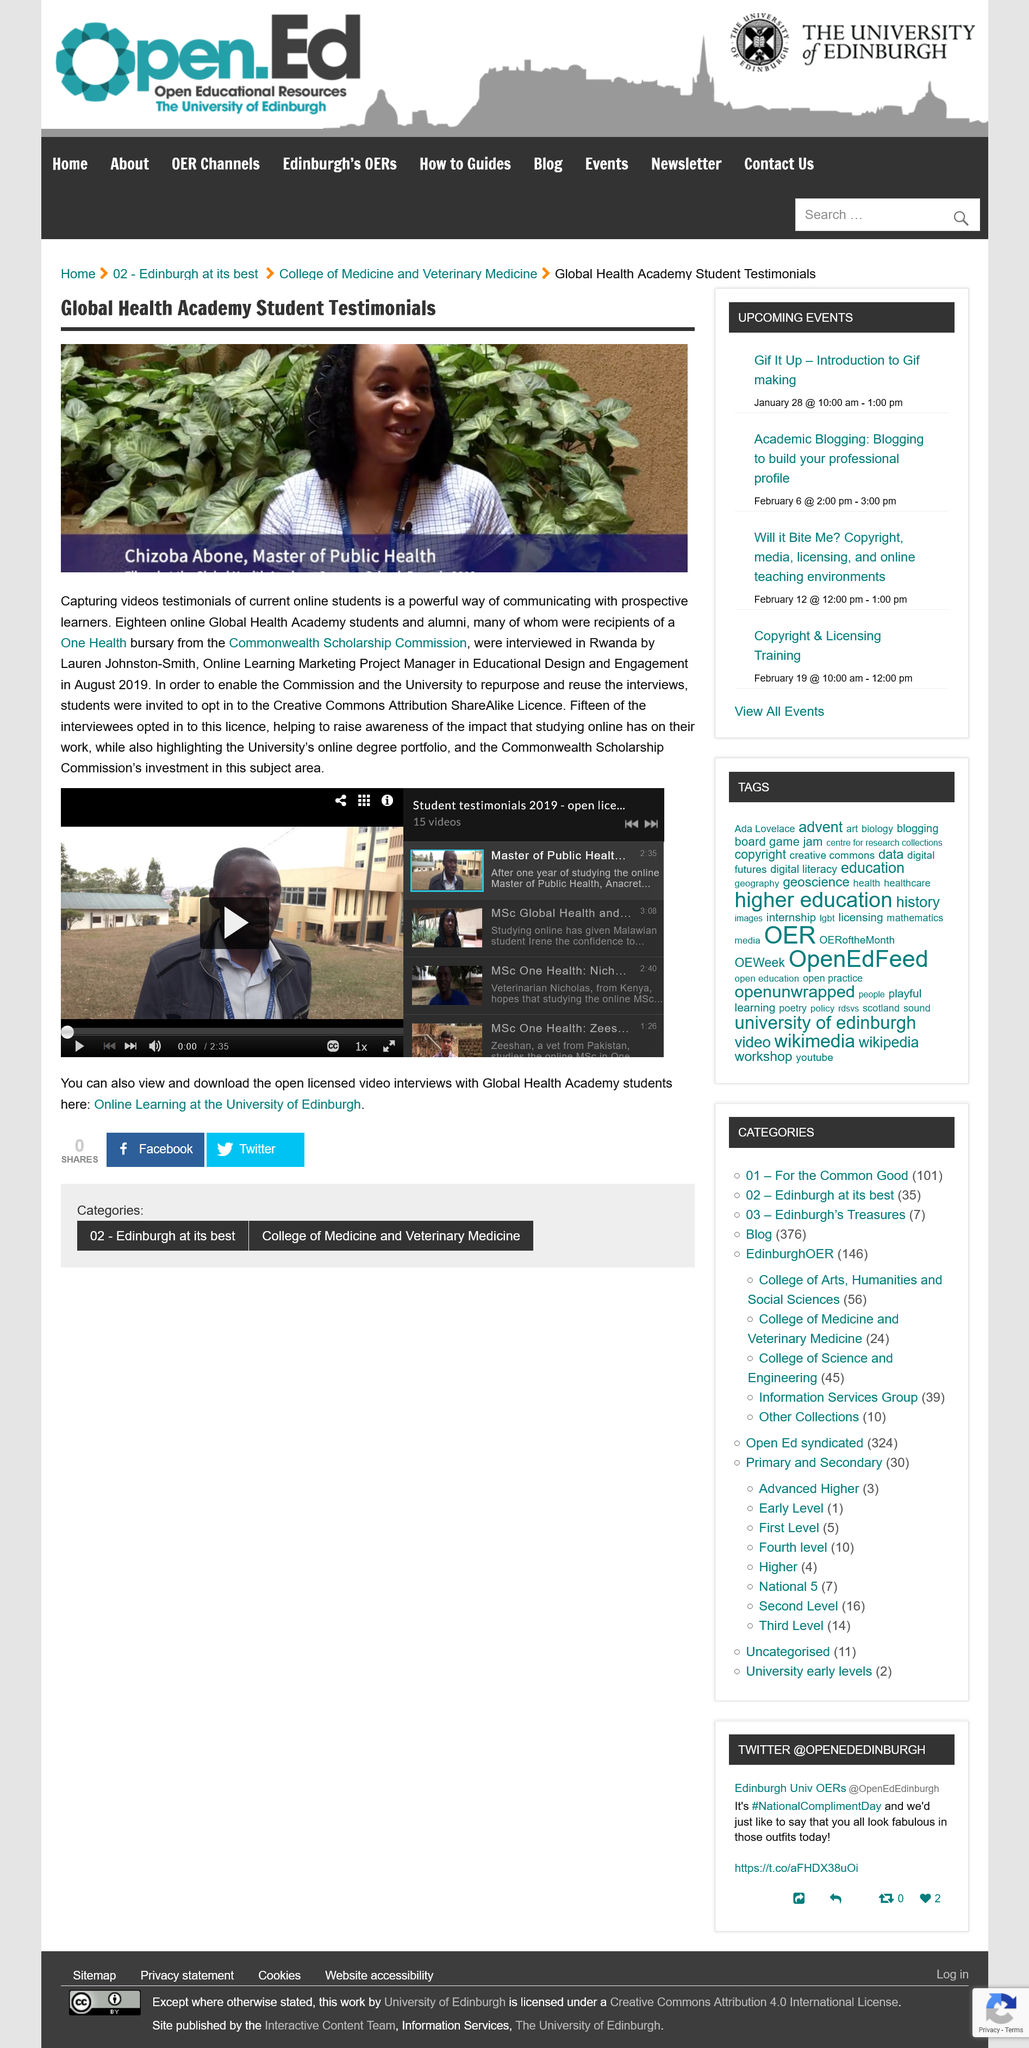Highlight a few significant elements in this photo. Chizoba Abone holds a Master of Public Health degree. The students were invited to choose to opt in to the Creative Commons Attribution ShareAlike License. This section is titled 'Global Health Academy Student Testimonials'. 